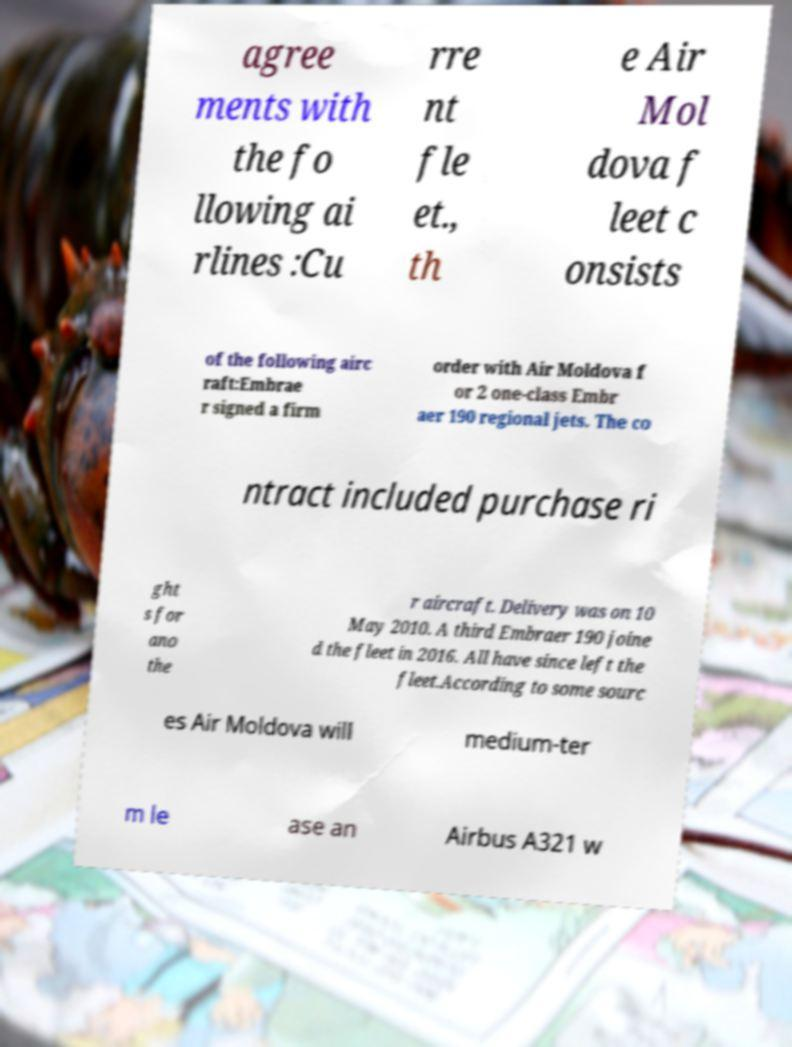Could you extract and type out the text from this image? agree ments with the fo llowing ai rlines :Cu rre nt fle et., th e Air Mol dova f leet c onsists of the following airc raft:Embrae r signed a firm order with Air Moldova f or 2 one-class Embr aer 190 regional jets. The co ntract included purchase ri ght s for ano the r aircraft. Delivery was on 10 May 2010. A third Embraer 190 joine d the fleet in 2016. All have since left the fleet.According to some sourc es Air Moldova will medium-ter m le ase an Airbus A321 w 